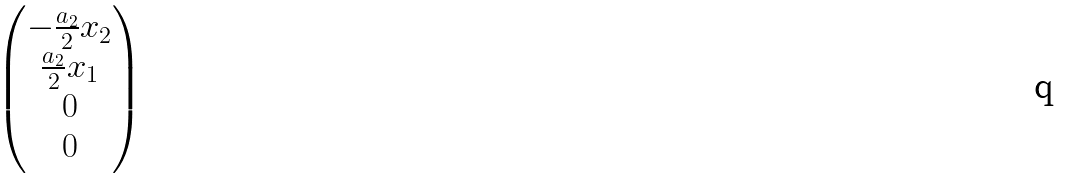<formula> <loc_0><loc_0><loc_500><loc_500>\begin{pmatrix} - \frac { a _ { 2 } } { 2 } x _ { 2 } \\ \frac { a _ { 2 } } { 2 } x _ { 1 } \\ 0 \\ 0 \end{pmatrix}</formula> 